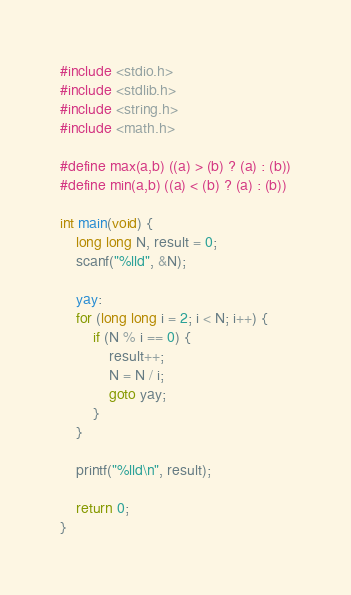Convert code to text. <code><loc_0><loc_0><loc_500><loc_500><_C_>#include <stdio.h>
#include <stdlib.h>
#include <string.h>
#include <math.h>
 
#define max(a,b) ((a) > (b) ? (a) : (b))
#define min(a,b) ((a) < (b) ? (a) : (b))

int main(void) {
	long long N, result = 0;
	scanf("%lld", &N);
	
	yay:
	for (long long i = 2; i < N; i++) {
		if (N % i == 0) {
			result++;
			N = N / i;
			goto yay;
		}
	}
	
	printf("%lld\n", result);
	
	return 0;
}</code> 